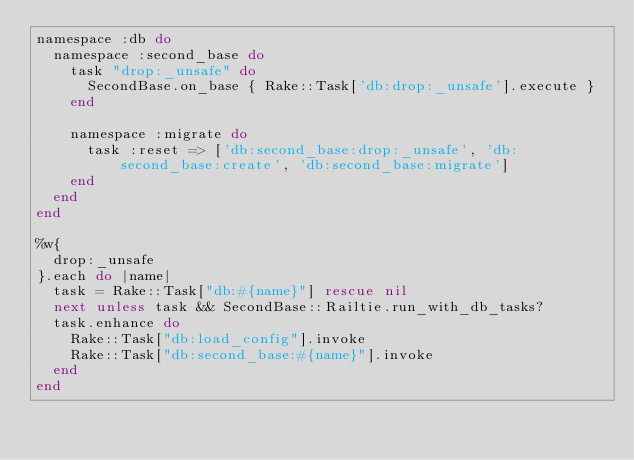<code> <loc_0><loc_0><loc_500><loc_500><_Ruby_>namespace :db do
  namespace :second_base do
    task "drop:_unsafe" do
      SecondBase.on_base { Rake::Task['db:drop:_unsafe'].execute }
    end

    namespace :migrate do
      task :reset => ['db:second_base:drop:_unsafe', 'db:second_base:create', 'db:second_base:migrate']
    end
  end
end

%w{
  drop:_unsafe
}.each do |name|
  task = Rake::Task["db:#{name}"] rescue nil
  next unless task && SecondBase::Railtie.run_with_db_tasks?
  task.enhance do
    Rake::Task["db:load_config"].invoke
    Rake::Task["db:second_base:#{name}"].invoke
  end
end
</code> 